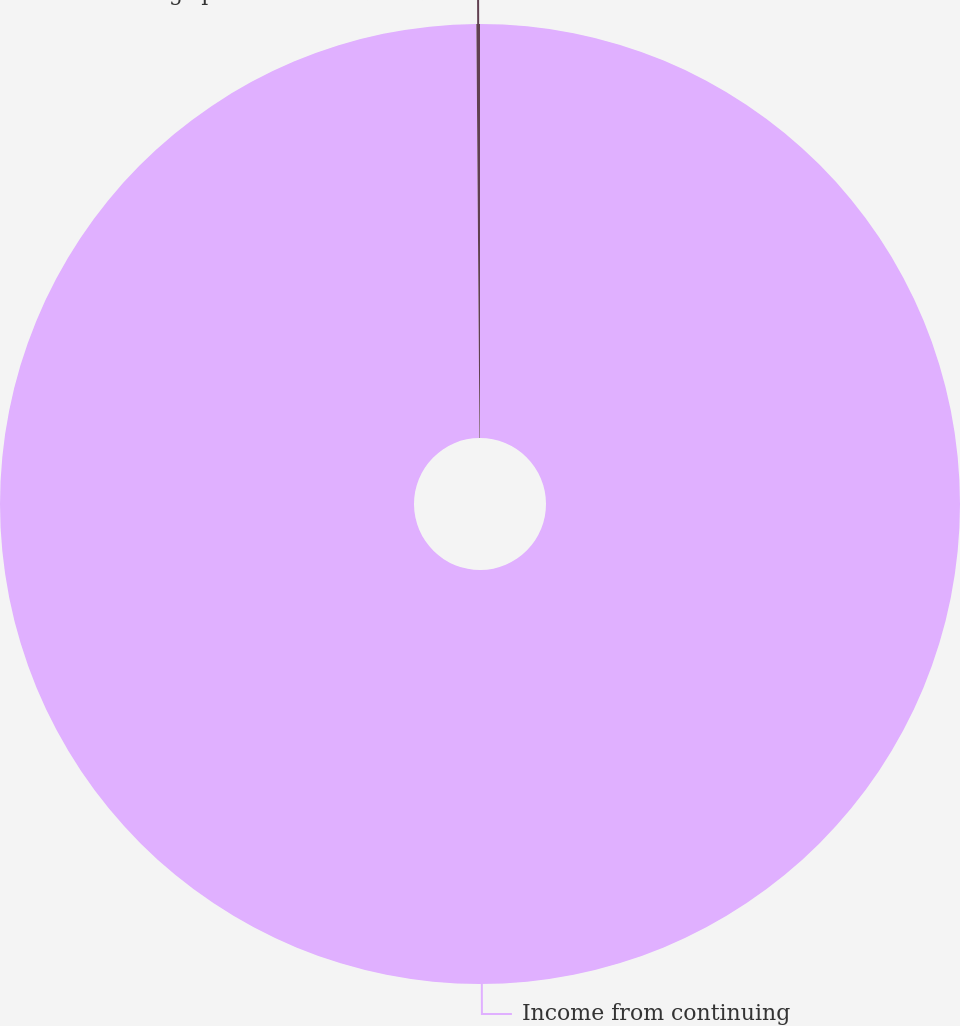<chart> <loc_0><loc_0><loc_500><loc_500><pie_chart><fcel>Income from continuing<fcel>Earnings per share of common<nl><fcel>99.88%<fcel>0.12%<nl></chart> 